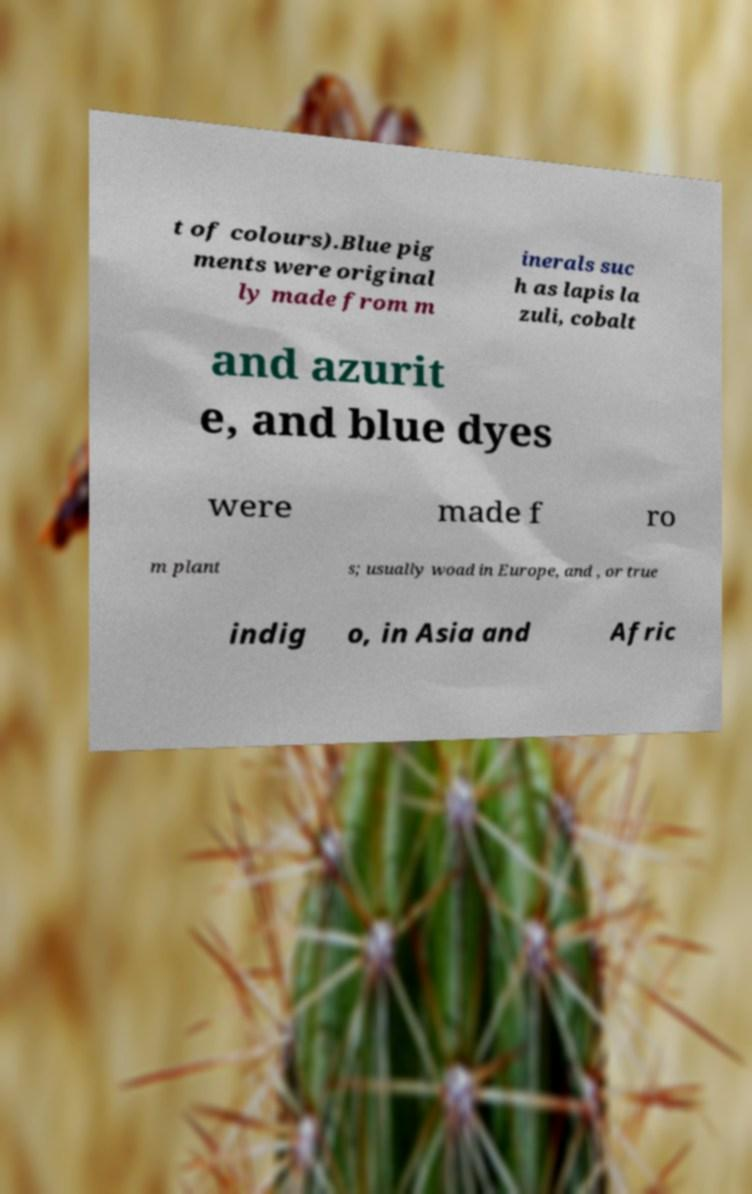Can you accurately transcribe the text from the provided image for me? t of colours).Blue pig ments were original ly made from m inerals suc h as lapis la zuli, cobalt and azurit e, and blue dyes were made f ro m plant s; usually woad in Europe, and , or true indig o, in Asia and Afric 